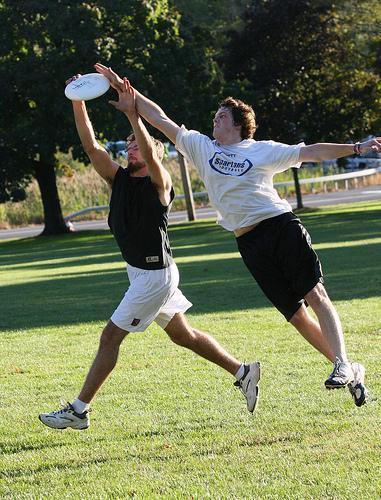How many people are pictured?
Give a very brief answer. 2. How many frisbees are pictured?
Give a very brief answer. 1. How many elephants are pictured?
Give a very brief answer. 0. 